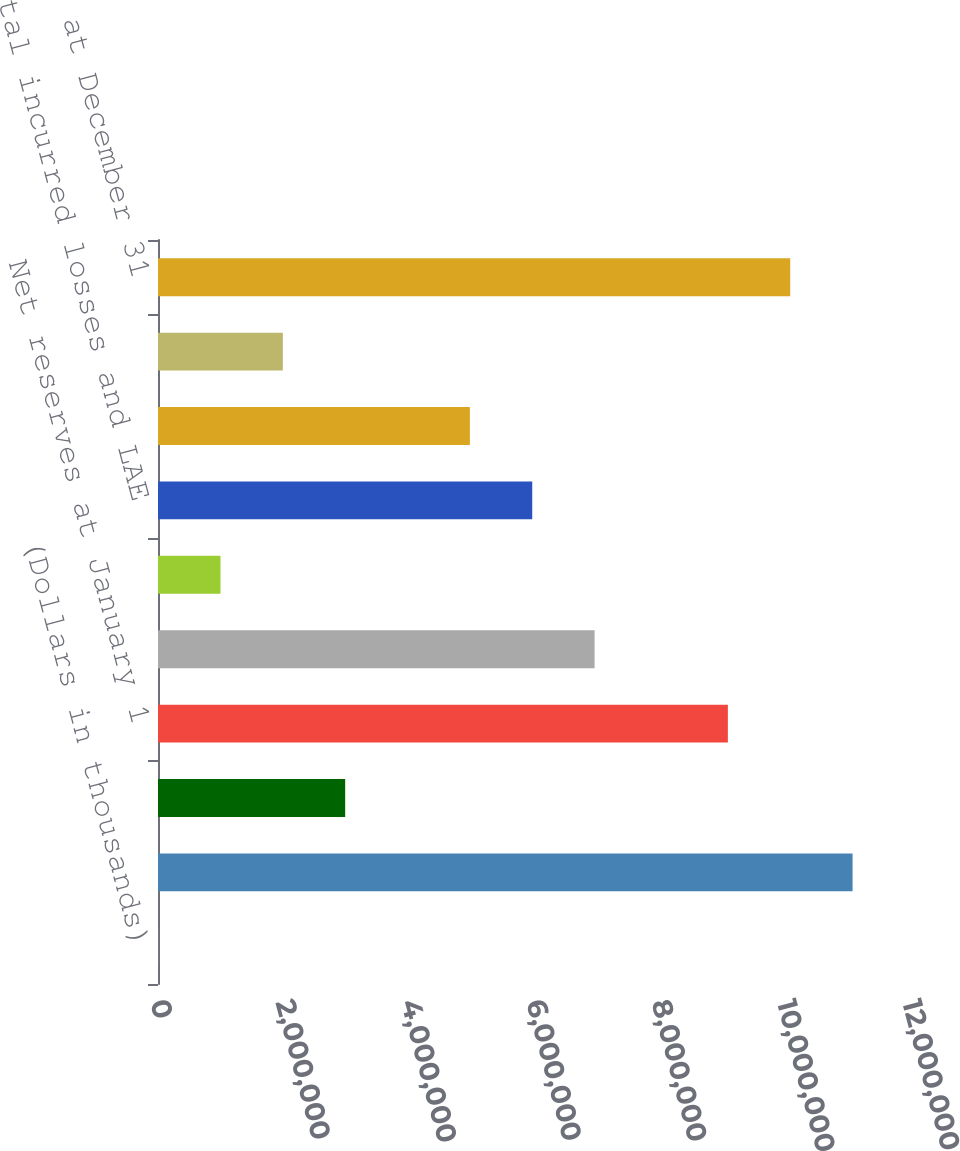<chart> <loc_0><loc_0><loc_500><loc_500><bar_chart><fcel>(Dollars in thousands)<fcel>Gross reserves at January 1<fcel>Less reinsurance recoverables<fcel>Net reserves at January 1<fcel>Current year<fcel>Prior years<fcel>Total incurred losses and LAE<fcel>Total paid losses and LAE<fcel>Foreign exchange/translation<fcel>Net reserves at December 31<nl><fcel>2015<fcel>1.10837e+07<fcel>2.98695e+06<fcel>9.09373e+06<fcel>6.96686e+06<fcel>996993<fcel>5.97188e+06<fcel>4.97691e+06<fcel>1.99197e+06<fcel>1.00887e+07<nl></chart> 